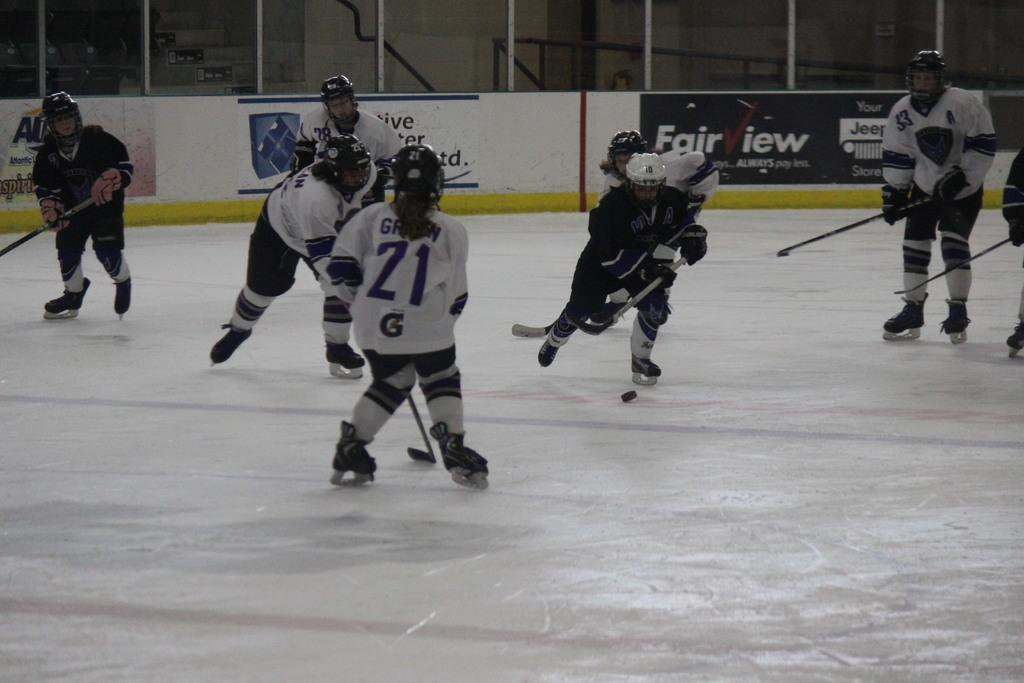How many people are in the image? There is a group of people in the image. What are the people holding in their hands? The people are holding sticks in their hands. What sport are the people playing in the image? The people are playing hockey. What type of surface is visible in the image? There is a floor visible in the image. What architectural features can be seen in the background of the image? There are boards, a pole, and a wall in the background of the image. What type of sweater is the person in the image wearing? There is no person wearing a sweater in the image; the people are wearing hockey gear. What type of system is being used to manage the game in the image? There is no system visible in the image; it is focused on the people playing hockey. 